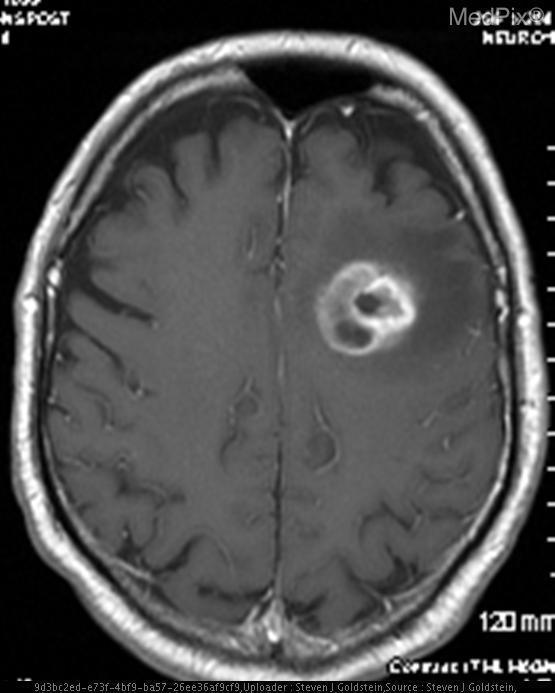How was this image taken?
Give a very brief answer. Mri. Is this image in the transverse plane?
Short answer required. Yes. Is there bleeding in the brain?
Answer briefly. No. Is there blurring of the grey-white matter junction?
Concise answer only. No. What abnormal findings are present in this image?
Answer briefly. Ring-enhancing lesion. What is the lesion in this image?
Keep it brief. Ring-enhancing lesion. Can you name the organ captured by this image?
Concise answer only. Brain. How would you describe the lesion?
Write a very short answer. Ring-enhancing. What is this type of lesion called?
Be succinct. Ring-enhancing. Is there edema present near the lesion?
Keep it brief. Yes. Is there fluid accumulation near the lesion?
Be succinct. Yes. 